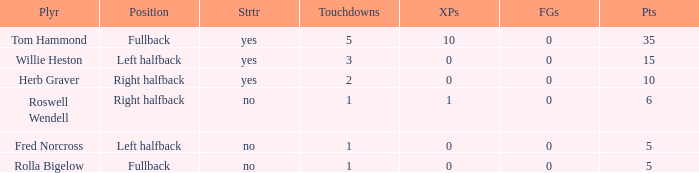How many extra points did right halfback Roswell Wendell have? 1.0. 